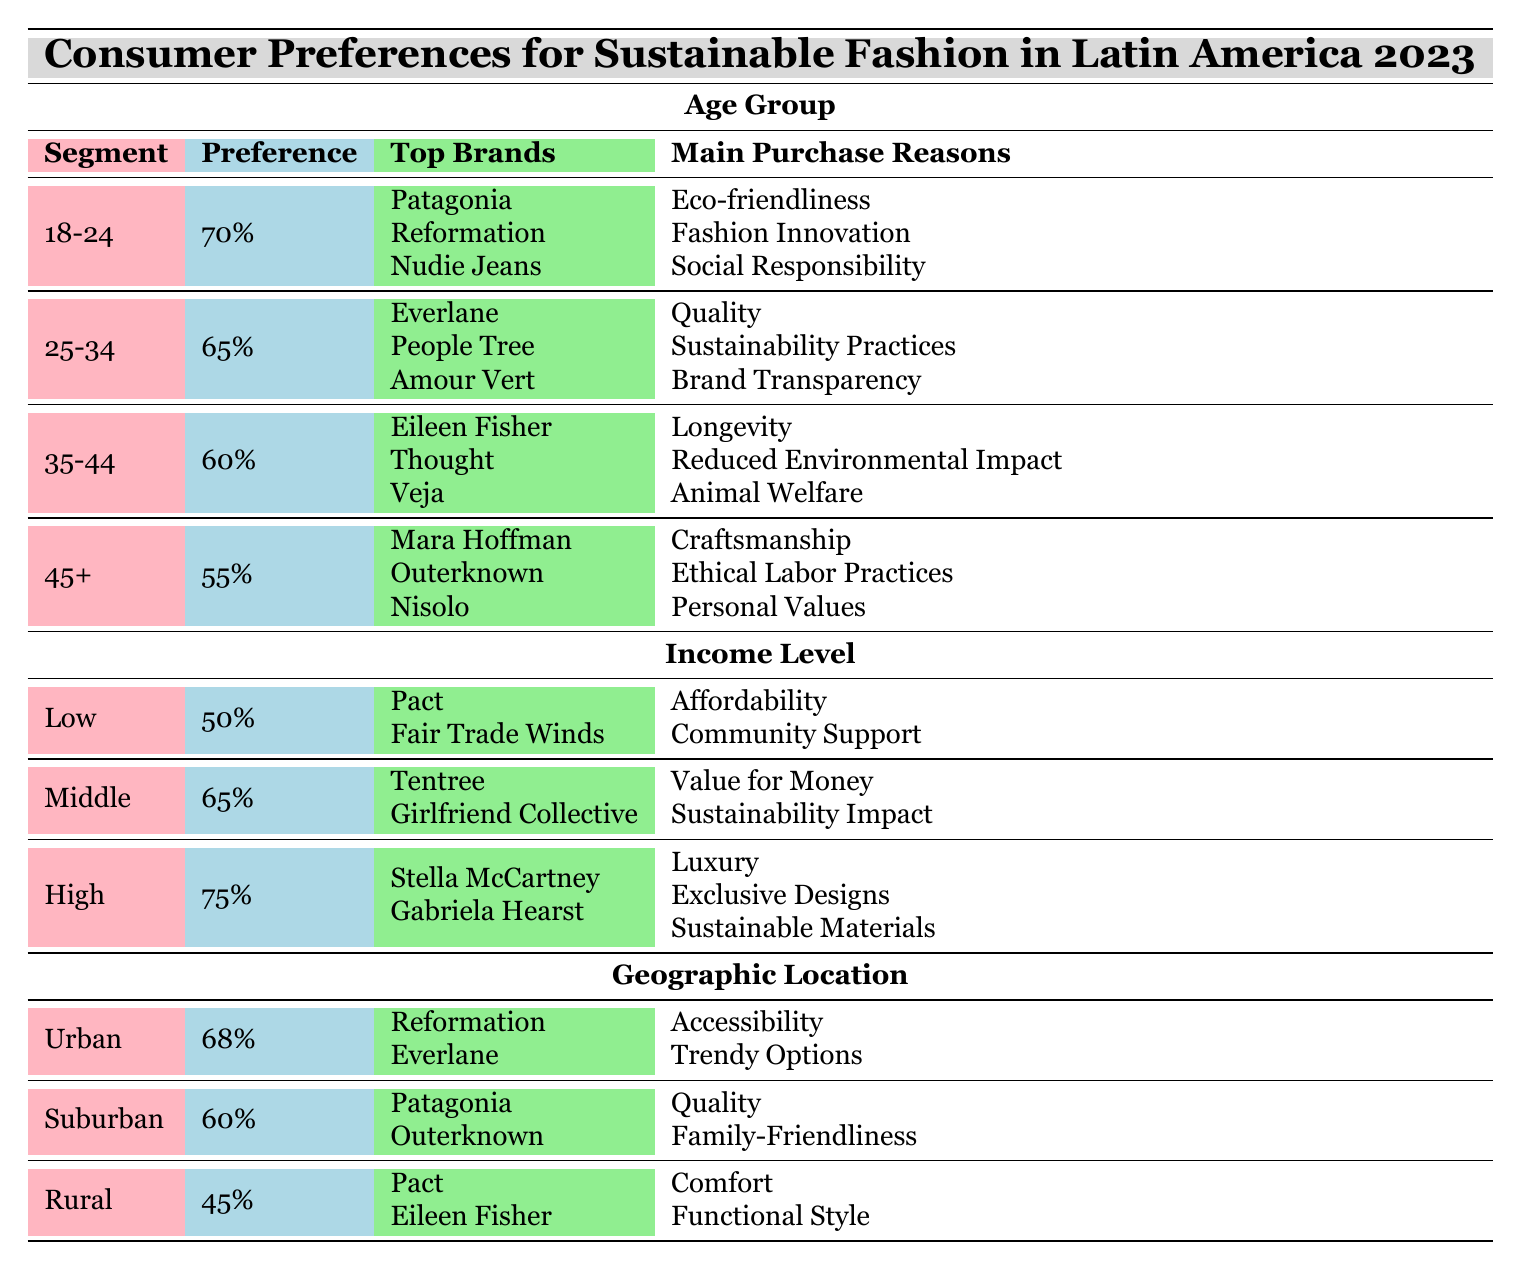What percentage of the 45+ age group prefers sustainable brands? According to the table, the 45+ age group has a preference of 55% for sustainable brands. This can be found directly by looking at the row corresponding to the 45+ age group under the age segments section.
Answer: 55% Which income level has the highest percentage of preference for sustainable brands? The table shows that the high-income level has the highest preference at 75%. This conclusion is drawn by comparing the preference percentages across all income levels: low (50%), middle (65%), and high (75%).
Answer: High What are the main purchase reasons for the 18-24 age group? The main purchase reasons for the 18-24 age group can be found in their respective row under the age group section. The reasons listed are eco-friendliness, fashion innovation, and social responsibility.
Answer: Eco-friendliness, fashion innovation, social responsibility Is there a higher preference for sustainable brands among urban consumers compared to rural consumers? Yes, urban consumers have a 68% preference for sustainable brands, while rural consumers only have a 45% preference, which confirms that urban consumers prefer sustainable brands more than rural consumers.
Answer: Yes What is the average preference percentage for sustainable brands across different age groups? The preferences for the age groups are 70%, 65%, 60%, and 55%. To find the average, sum these percentages (70 + 65 + 60 + 55 = 250) and divide by the number of groups (4), resulting in 250/4 = 62.5%.
Answer: 62.5% Which brand is preferred most among consumers aged 25-34? The top brand for the 25-34 age group is Everlane. This is indicated in the corresponding row for this age group under the top brands section.
Answer: Everlane Are consumers in rural areas more likely to purchase sustainable brands than those with a low income level? No, rural consumers have a 45% preference for sustainable brands, while low-income consumers have a 50% preference, indicating that low-income consumers are slightly more likely to purchase sustainable brands than rural ones.
Answer: No What are the top brands preferred by consumers in the suburban location category? For suburban consumers, the top brands listed are Patagonia and Outerknown. This can be directly referenced from the respective row in the geographic location section.
Answer: Patagonia, Outerknown 